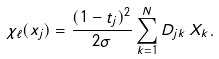<formula> <loc_0><loc_0><loc_500><loc_500>\chi _ { \ell } ( x _ { j } ) = \frac { ( 1 - t _ { j } ) ^ { 2 } } { 2 \sigma } \sum _ { k = 1 } ^ { N } D _ { j k } \, X _ { k } .</formula> 